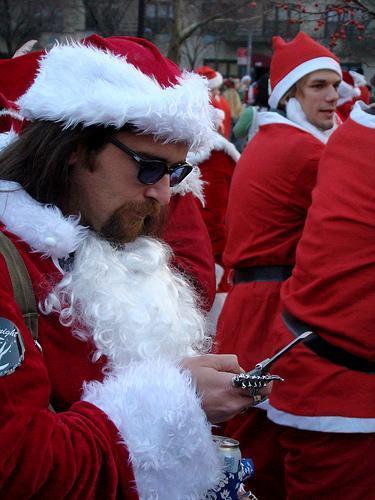How many belts are clearly visible in the photo?
Give a very brief answer. 2. 